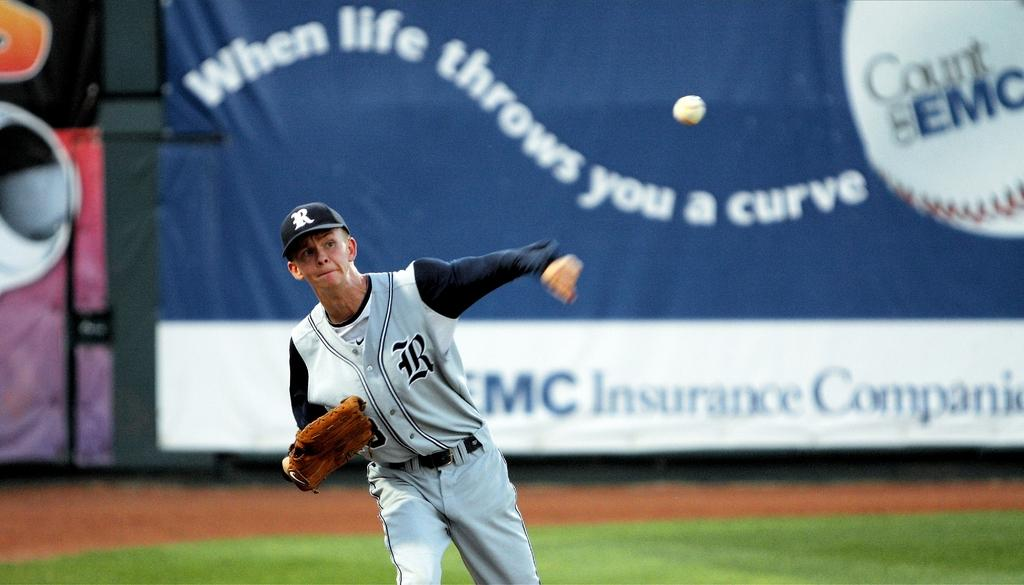<image>
Relay a brief, clear account of the picture shown. A baseball player with a R on his cap throwing the ball. 